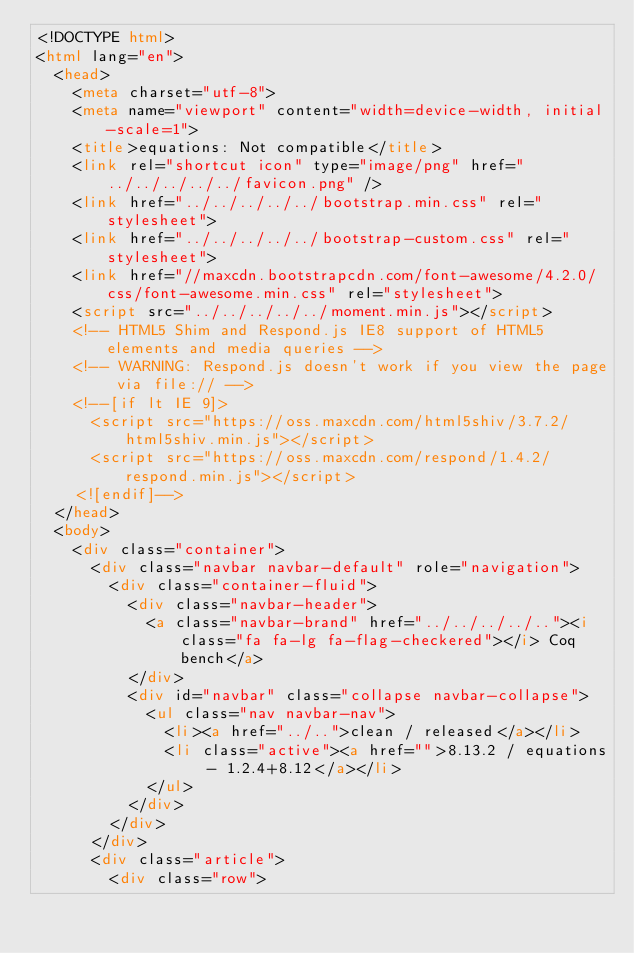Convert code to text. <code><loc_0><loc_0><loc_500><loc_500><_HTML_><!DOCTYPE html>
<html lang="en">
  <head>
    <meta charset="utf-8">
    <meta name="viewport" content="width=device-width, initial-scale=1">
    <title>equations: Not compatible</title>
    <link rel="shortcut icon" type="image/png" href="../../../../../favicon.png" />
    <link href="../../../../../bootstrap.min.css" rel="stylesheet">
    <link href="../../../../../bootstrap-custom.css" rel="stylesheet">
    <link href="//maxcdn.bootstrapcdn.com/font-awesome/4.2.0/css/font-awesome.min.css" rel="stylesheet">
    <script src="../../../../../moment.min.js"></script>
    <!-- HTML5 Shim and Respond.js IE8 support of HTML5 elements and media queries -->
    <!-- WARNING: Respond.js doesn't work if you view the page via file:// -->
    <!--[if lt IE 9]>
      <script src="https://oss.maxcdn.com/html5shiv/3.7.2/html5shiv.min.js"></script>
      <script src="https://oss.maxcdn.com/respond/1.4.2/respond.min.js"></script>
    <![endif]-->
  </head>
  <body>
    <div class="container">
      <div class="navbar navbar-default" role="navigation">
        <div class="container-fluid">
          <div class="navbar-header">
            <a class="navbar-brand" href="../../../../.."><i class="fa fa-lg fa-flag-checkered"></i> Coq bench</a>
          </div>
          <div id="navbar" class="collapse navbar-collapse">
            <ul class="nav navbar-nav">
              <li><a href="../..">clean / released</a></li>
              <li class="active"><a href="">8.13.2 / equations - 1.2.4+8.12</a></li>
            </ul>
          </div>
        </div>
      </div>
      <div class="article">
        <div class="row"></code> 